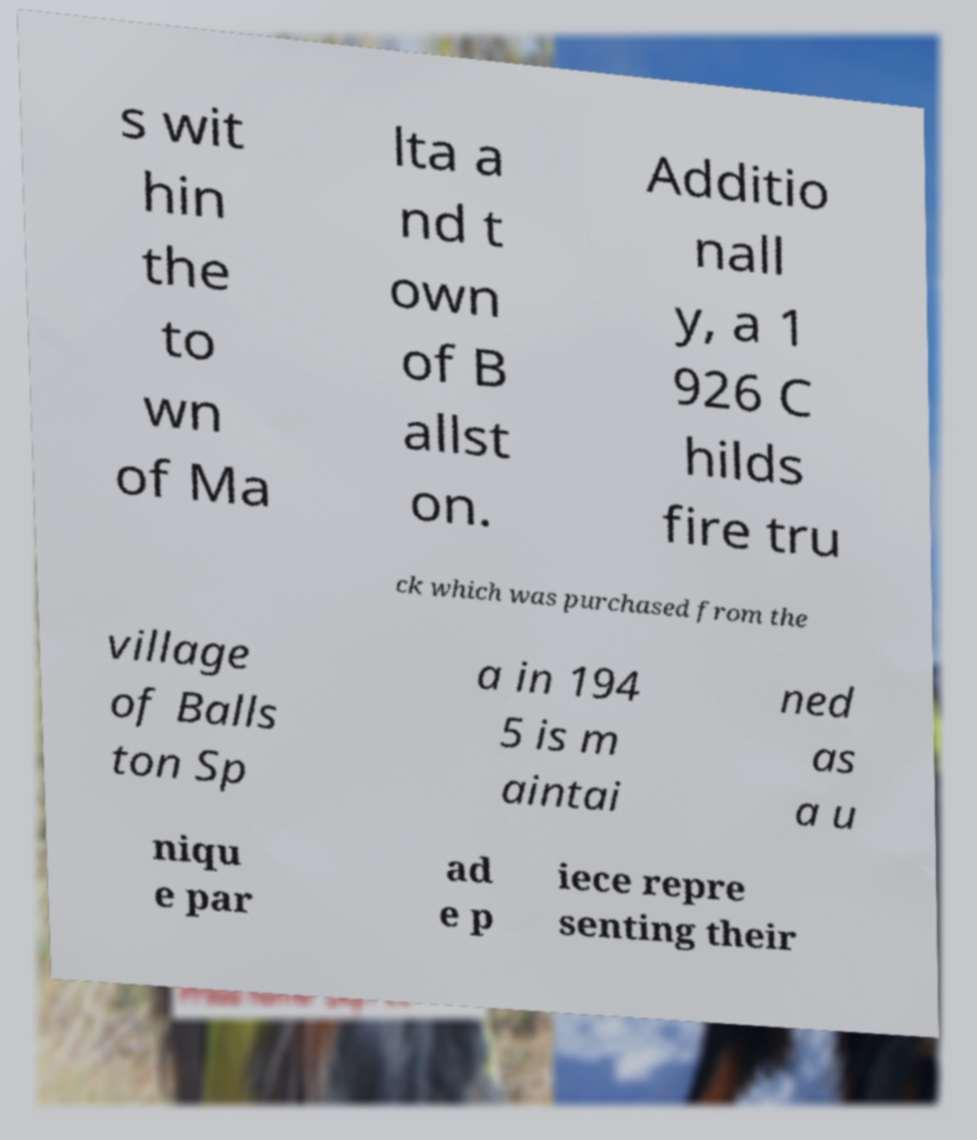I need the written content from this picture converted into text. Can you do that? s wit hin the to wn of Ma lta a nd t own of B allst on. Additio nall y, a 1 926 C hilds fire tru ck which was purchased from the village of Balls ton Sp a in 194 5 is m aintai ned as a u niqu e par ad e p iece repre senting their 